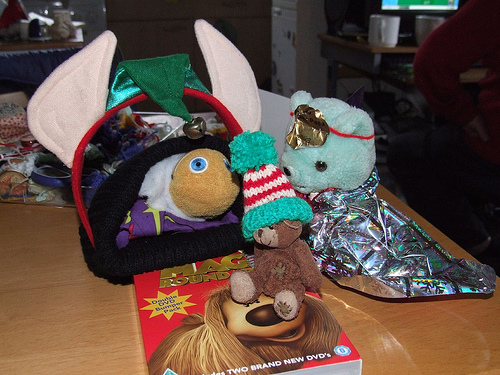<image>
Can you confirm if the bear is on the table? Yes. Looking at the image, I can see the bear is positioned on top of the table, with the table providing support. Is the cup behind the doll? Yes. From this viewpoint, the cup is positioned behind the doll, with the doll partially or fully occluding the cup. 